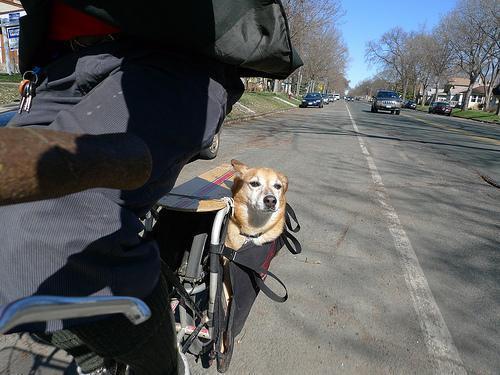How many human faces are visible?
Give a very brief answer. 0. 